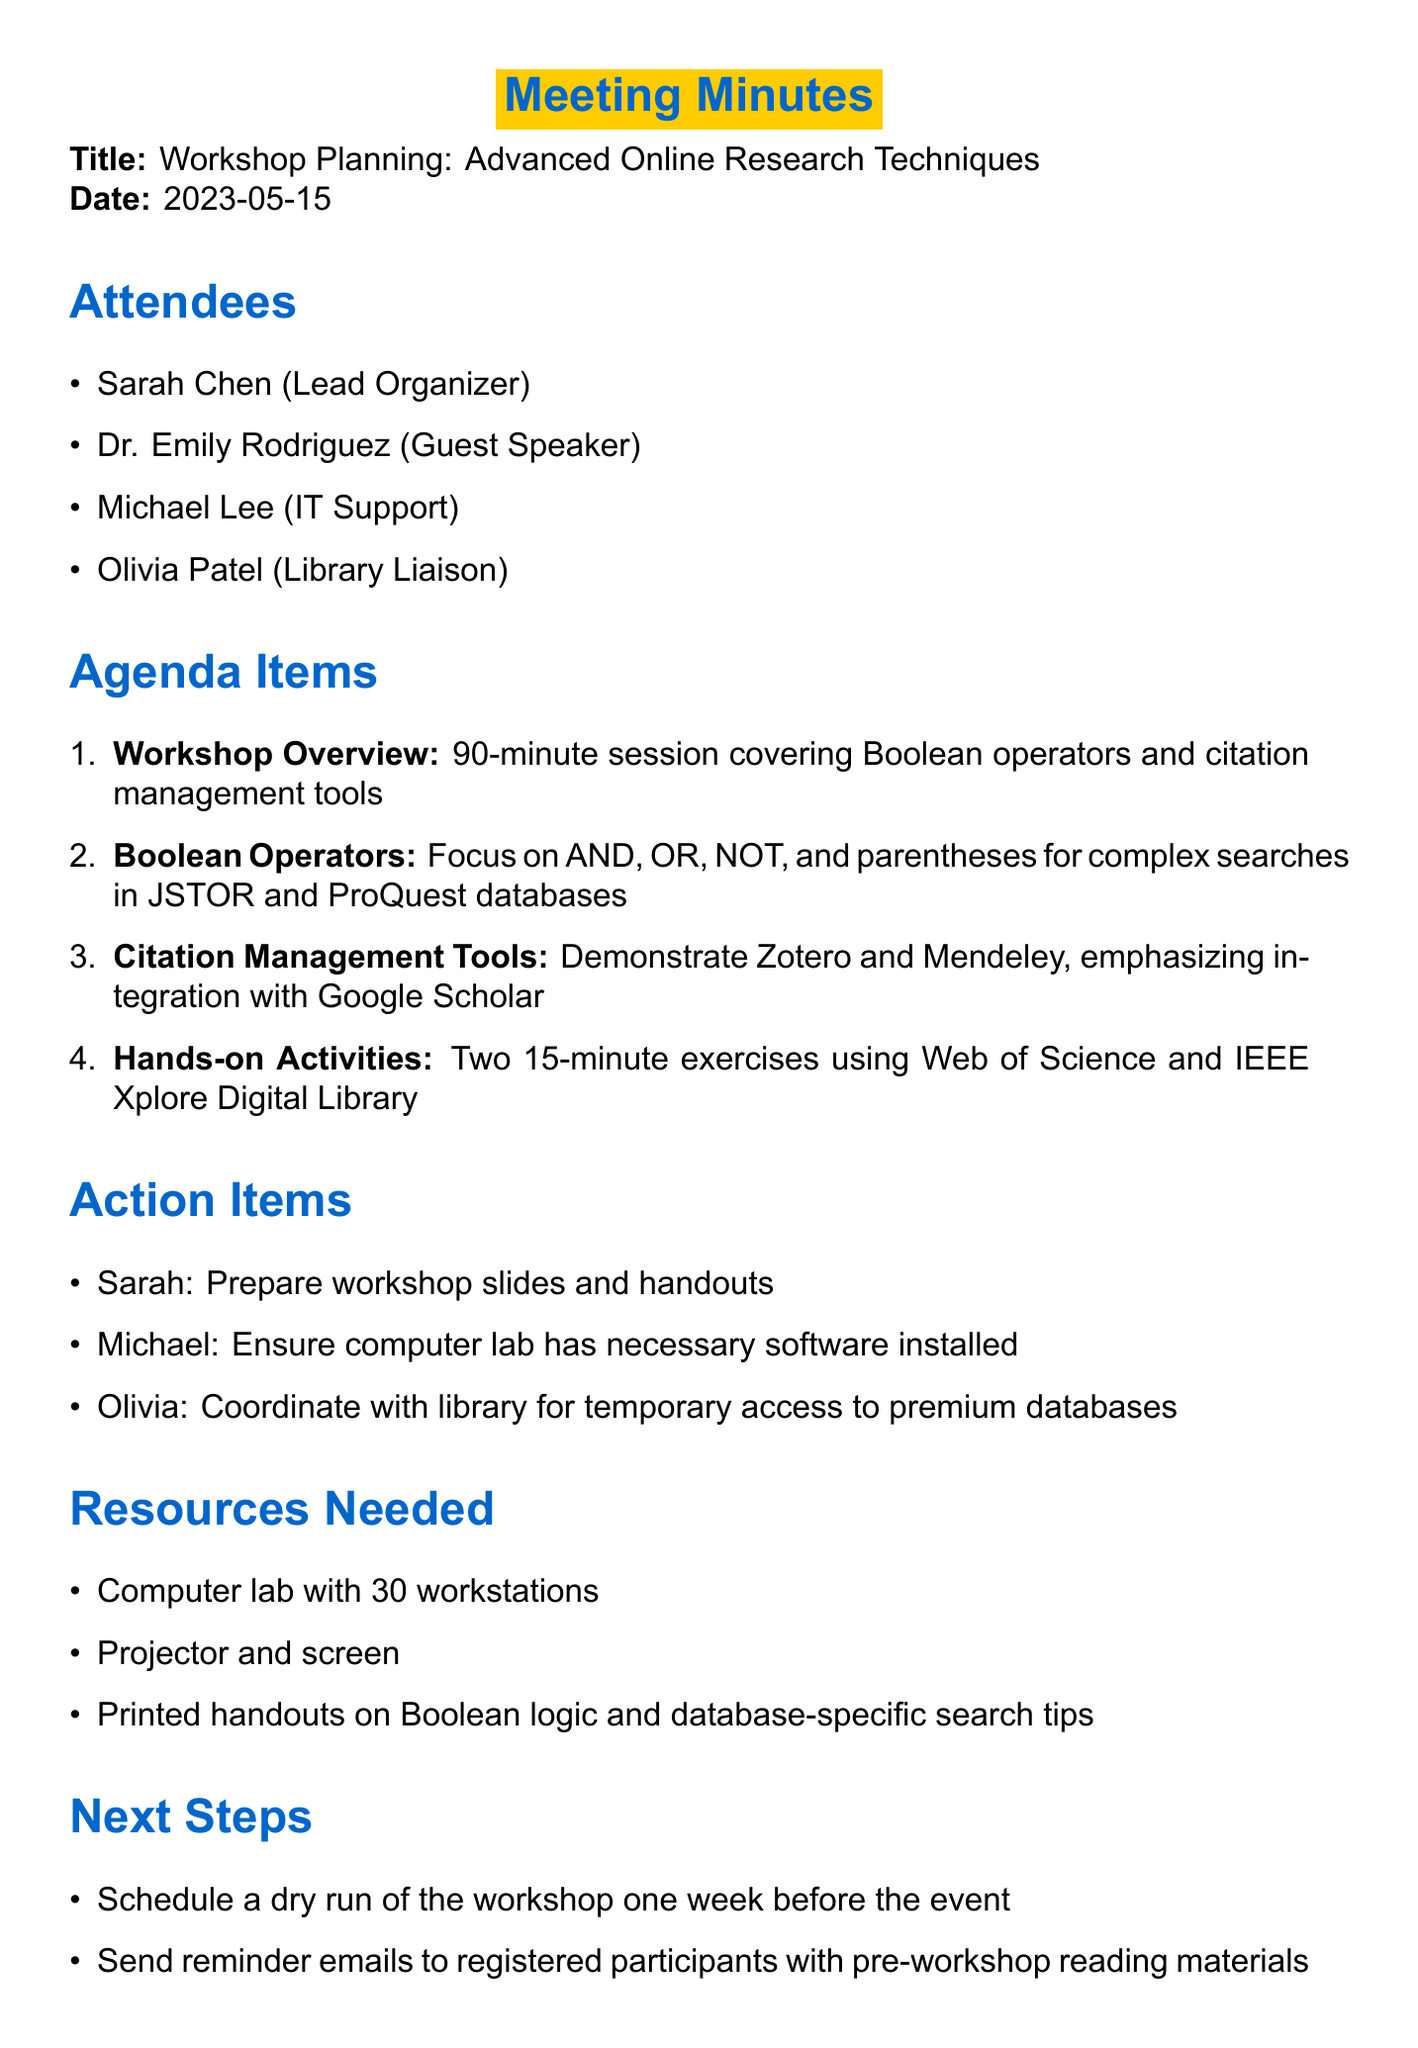What is the date of the meeting? The date of the meeting is specified in the document, which states "2023-05-15".
Answer: 2023-05-15 Who is the Lead Organizer of the workshop? The document lists attendees and identifies Sarah Chen as the Lead Organizer.
Answer: Sarah Chen What is the total duration of the workshop? The workshop overview indicates that it is a "90-minute session".
Answer: 90-minute Which citation management tools will be demonstrated? The agenda mentions two specific tools: Zotero and Mendeley.
Answer: Zotero and Mendeley What are the names of the databases mentioned for Boolean operators? The document specifically refers to JSTOR and ProQuest for Boolean searches.
Answer: JSTOR and ProQuest Who is responsible for preparing the workshop slides and handouts? The action items assign this responsibility to Sarah.
Answer: Sarah How many workstations are needed in the computer lab? The resources needed section indicates a "Computer lab with 30 workstations".
Answer: 30 What is one of the next steps mentioned in the document? The document lists scheduling a dry run of the workshop as a next step.
Answer: Schedule a dry run What type of activities will be included in the workshop? The agenda includes "Two 15-minute exercises" as hands-on activities.
Answer: Two 15-minute exercises 